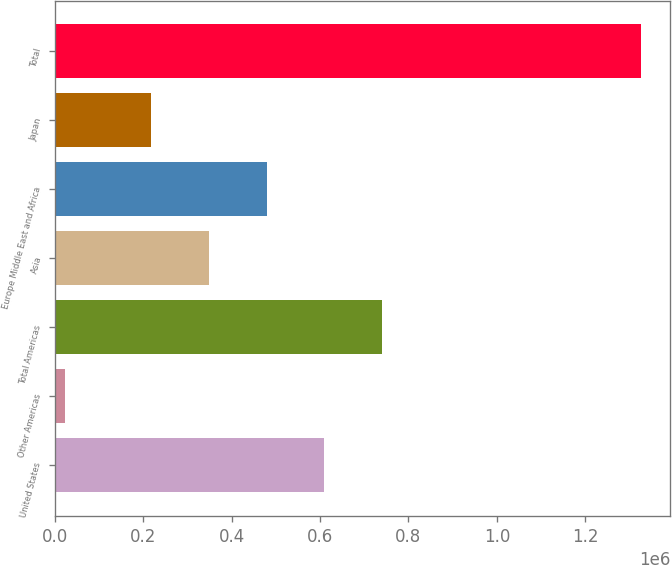Convert chart to OTSL. <chart><loc_0><loc_0><loc_500><loc_500><bar_chart><fcel>United States<fcel>Other Americas<fcel>Total Americas<fcel>Asia<fcel>Europe Middle East and Africa<fcel>Japan<fcel>Total<nl><fcel>609768<fcel>22967<fcel>740114<fcel>349077<fcel>479422<fcel>218731<fcel>1.32642e+06<nl></chart> 